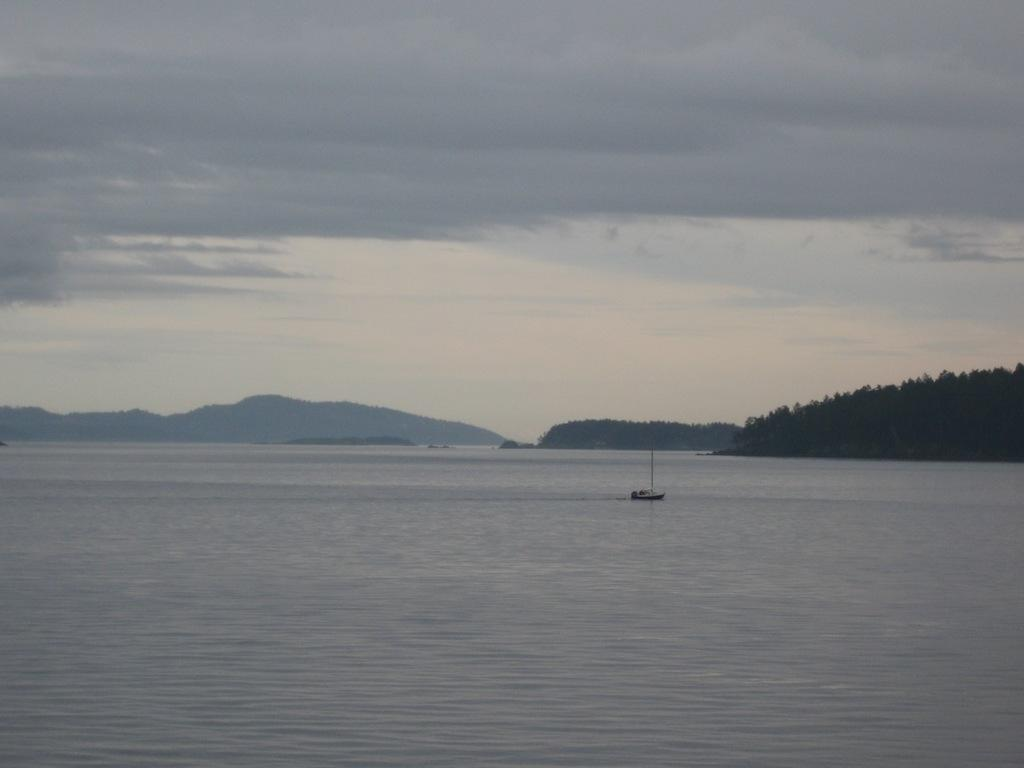What is the main feature of the image? The main feature of the image is water. What can be seen floating on the water? There is a boat in the image. What type of natural environment is depicted in the image? The image features trees and hills. What is visible above the water and land? The sky is visible in the image. What can be observed in the sky? Clouds are present in the sky. How does the idea float in the air in the image? There is no idea floating in the air in the image; it is not a subject present in the image. 